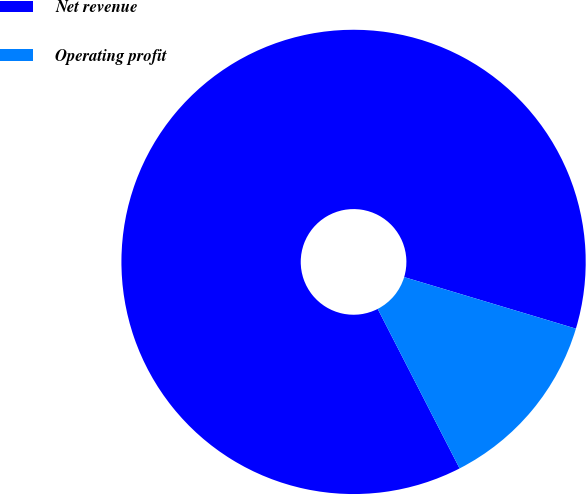<chart> <loc_0><loc_0><loc_500><loc_500><pie_chart><fcel>Net revenue<fcel>Operating profit<nl><fcel>87.19%<fcel>12.81%<nl></chart> 